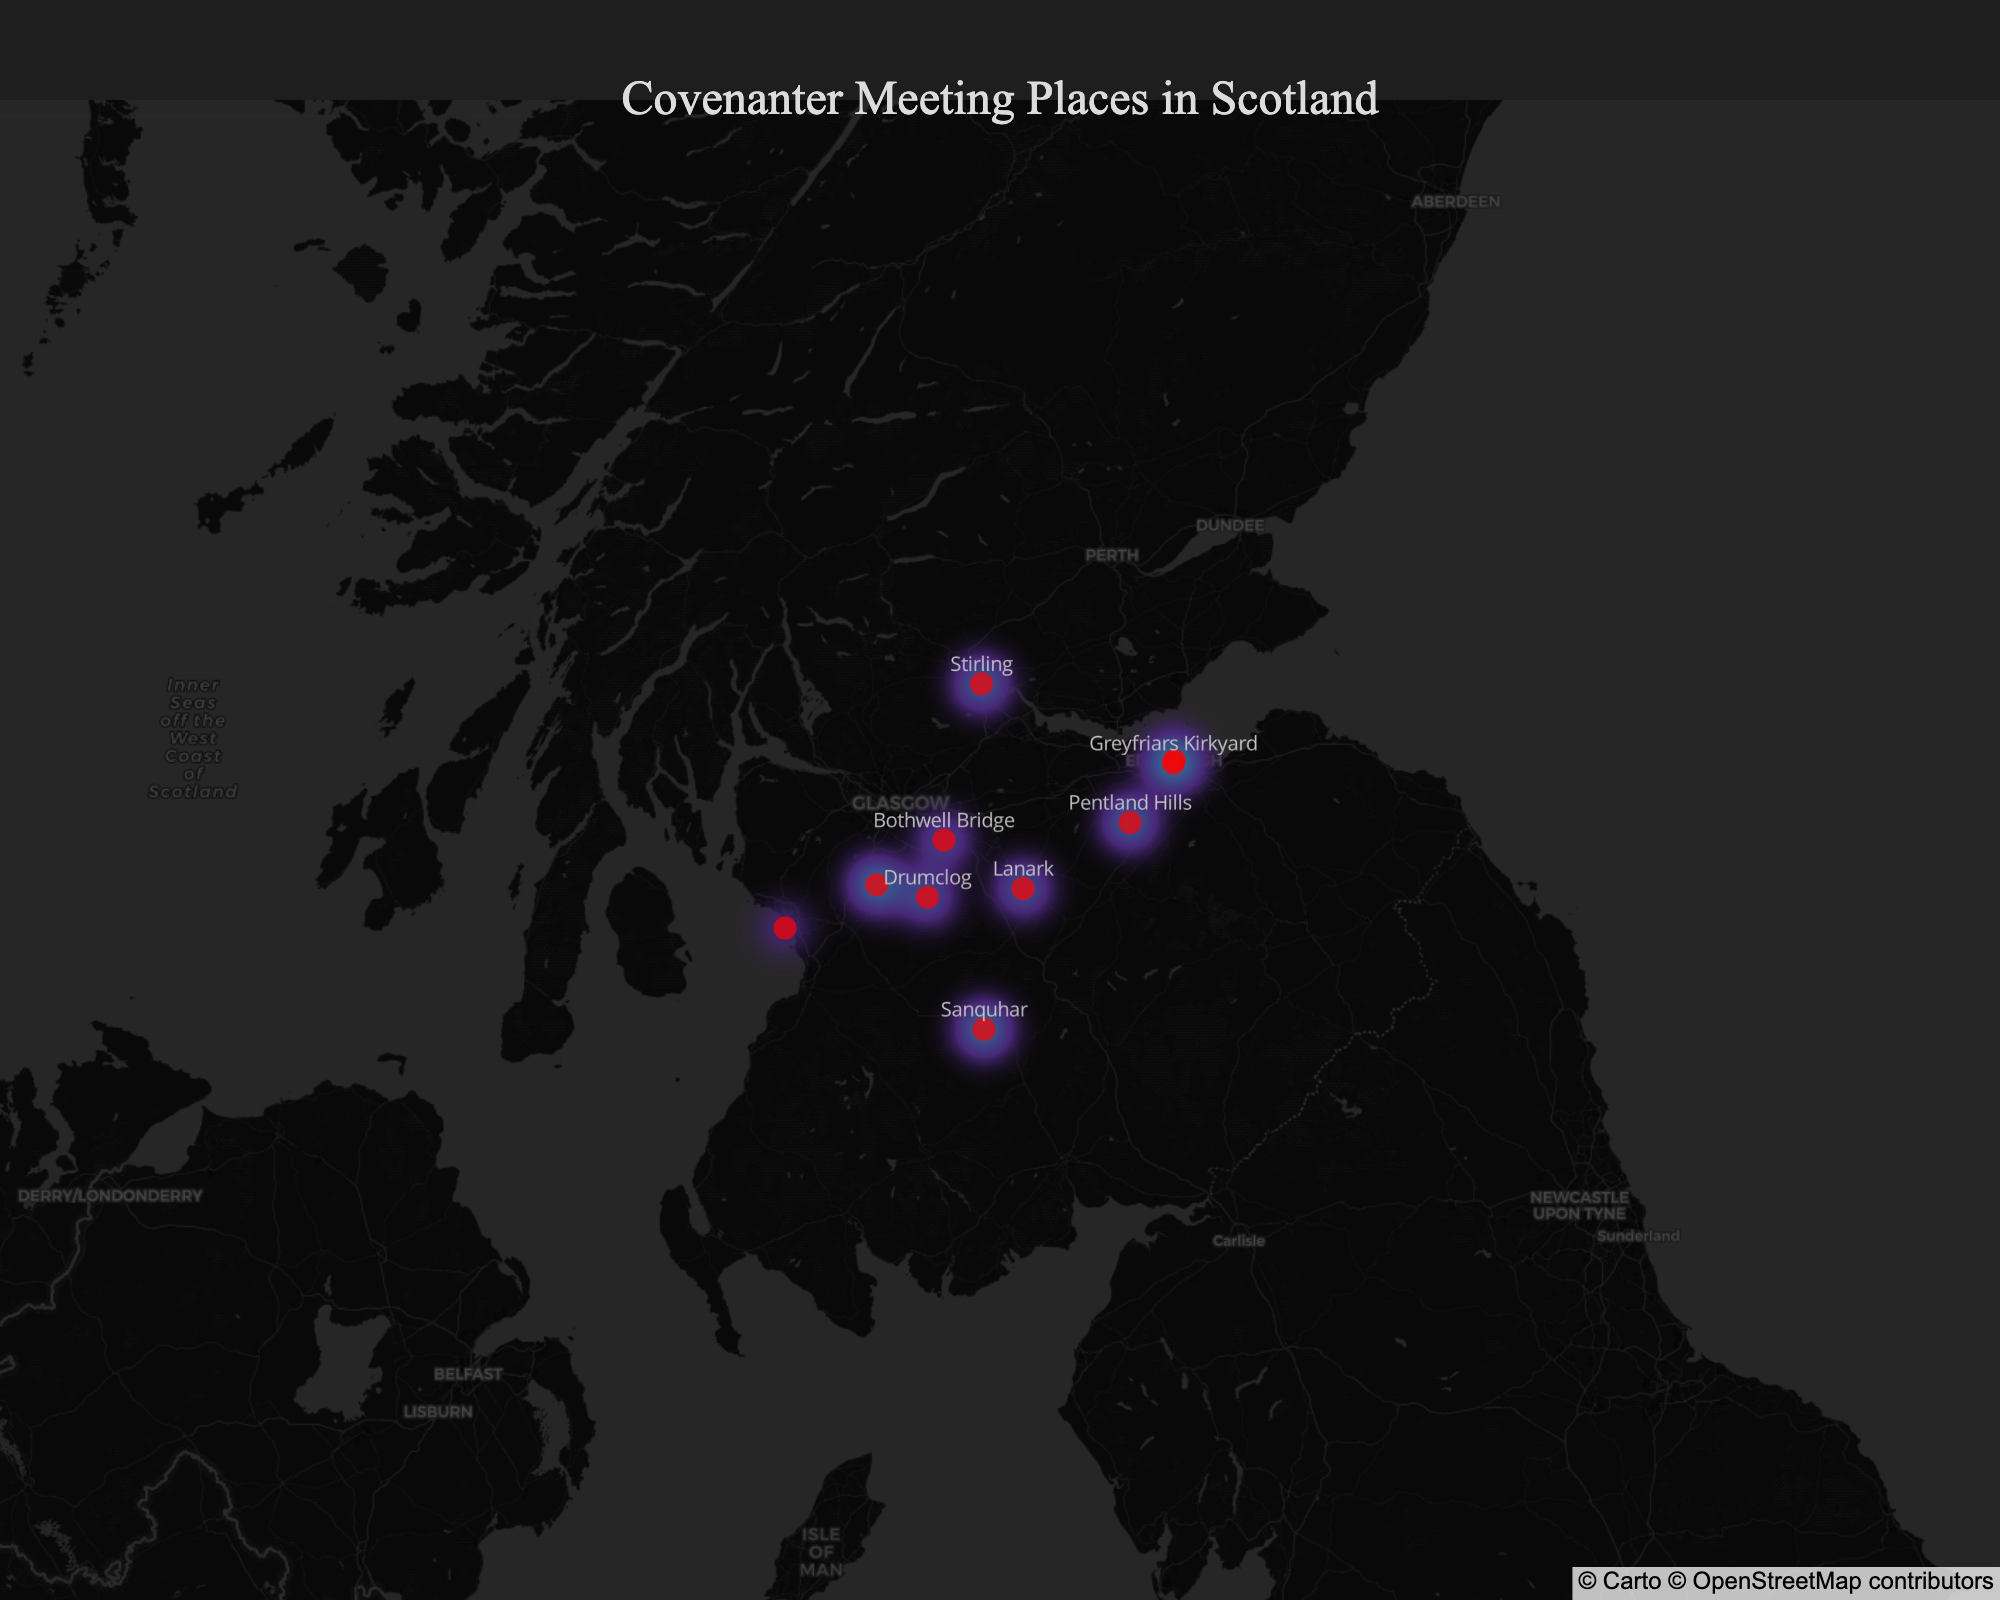What is the title of the figure? The title is displayed at the top center of the figure. It reads "Covenanter Meeting Places in Scotland."
Answer: Covenanter Meeting Places in Scotland How many meeting places are marked on this map? Count the number of markers or labeled locations in the figure. Each marker represents a meeting place.
Answer: 10 What location has the southernmost latitude? Compare the latitude values of all locations and identify the smallest value. This represents the southernmost point.
Answer: Sanquhar Which location is characterized as the "Site of the signing of the National Covenant in 1638"? Look at the hover text or markers to identify the location with this historical significance.
Answer: Greyfriars Kirkyard Which meeting place is located furthest west on the map? Compare the longitude values of all meeting places and identify the largest (most negative) value.
Answer: Auchencloigh Castle What is the central hub of Covenanter activities and trials? Refer to the hover text or markers to find the location described as the central hub for Covenanter activities and trials.
Answer: Edinburgh Which two locations are closest to each other based on latitude and longitude? Examine the plotted points visually to see which markers are nearest each other, or compare the latitude and longitude values.
Answer: Bothwell Bridge and Drumclog Are there more meeting places with significant battles or locations without battles? Categorize the meeting places by whether they are battle sites or not, and count each category. Examples of significant battles include Drumclog and Bothwell Bridge.
Answer: More without battles Which location is known for its open-air conventicles? Check the hover text for each marker to find which location is described as having open-air conventicles.
Answer: Lanark What is the historical significance of Sanquhar? Look at the hover text for Sanquhar on the map to find its historical significance.
Answer: Where the Sanquhar Declaration was proclaimed in 1680 